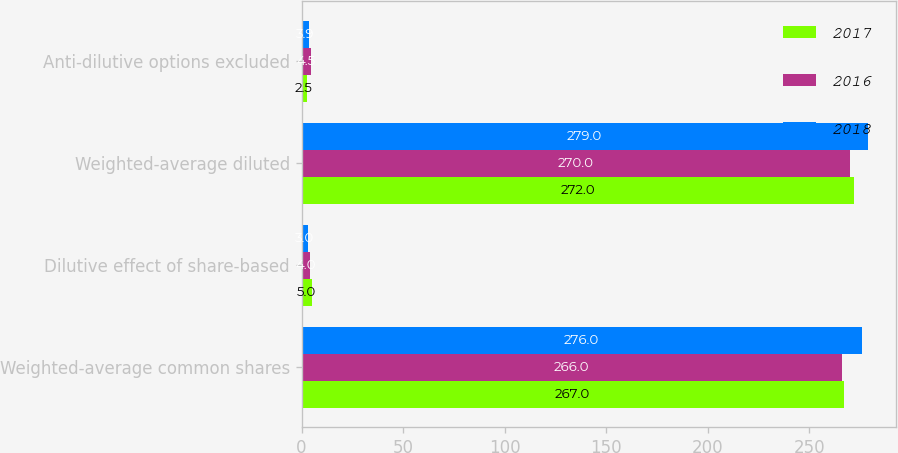<chart> <loc_0><loc_0><loc_500><loc_500><stacked_bar_chart><ecel><fcel>Weighted-average common shares<fcel>Dilutive effect of share-based<fcel>Weighted-average diluted<fcel>Anti-dilutive options excluded<nl><fcel>2017<fcel>267<fcel>5<fcel>272<fcel>2.5<nl><fcel>2016<fcel>266<fcel>4<fcel>270<fcel>4.5<nl><fcel>2018<fcel>276<fcel>3<fcel>279<fcel>3.9<nl></chart> 